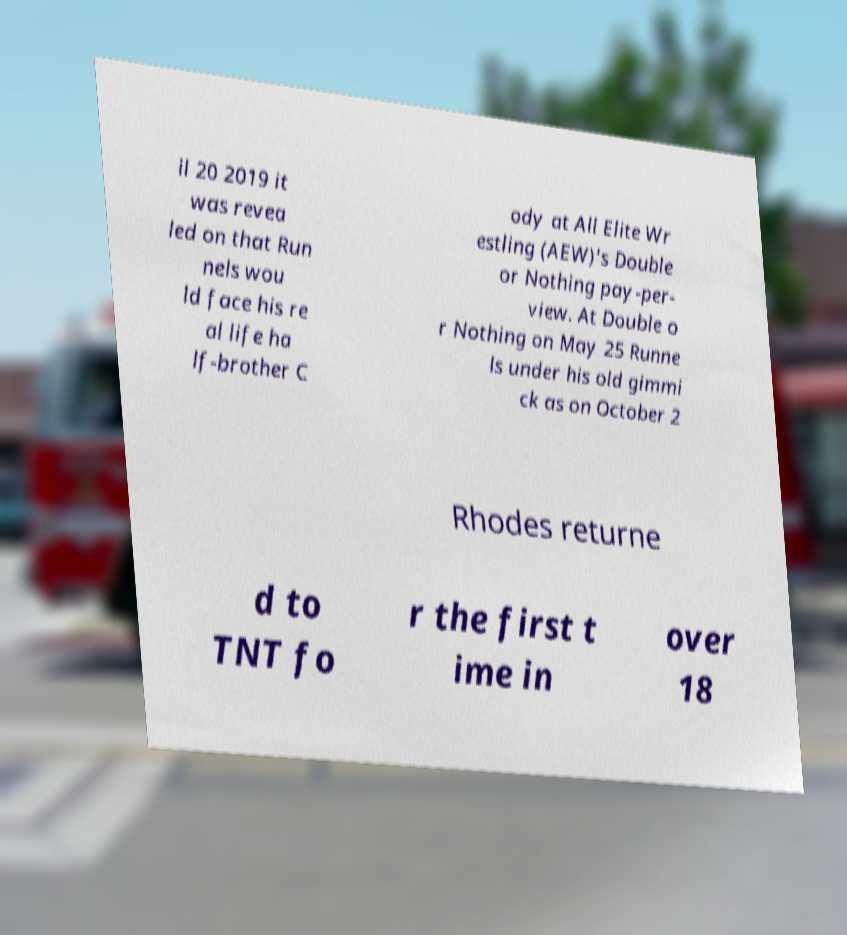Please identify and transcribe the text found in this image. il 20 2019 it was revea led on that Run nels wou ld face his re al life ha lf-brother C ody at All Elite Wr estling (AEW)'s Double or Nothing pay-per- view. At Double o r Nothing on May 25 Runne ls under his old gimmi ck as on October 2 Rhodes returne d to TNT fo r the first t ime in over 18 